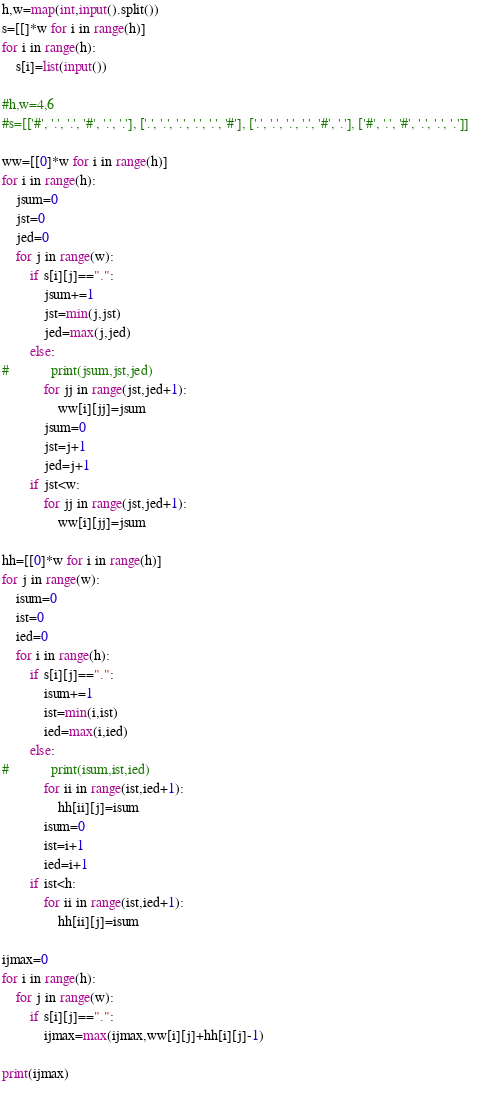<code> <loc_0><loc_0><loc_500><loc_500><_Python_>h,w=map(int,input().split())
s=[[]*w for i in range(h)]
for i in range(h):
    s[i]=list(input())

#h,w=4,6
#s=[['#', '.', '.', '#', '.', '.'], ['.', '.', '.', '.', '.', '#'], ['.', '.', '.', '.', '#', '.'], ['#', '.', '#', '.', '.', '.']]    

ww=[[0]*w for i in range(h)]
for i in range(h):
    jsum=0
    jst=0
    jed=0
    for j in range(w):
        if s[i][j]==".":
            jsum+=1
            jst=min(j,jst)
            jed=max(j,jed)
        else:
#            print(jsum,jst,jed)
            for jj in range(jst,jed+1):
                ww[i][jj]=jsum
            jsum=0
            jst=j+1
            jed=j+1
        if jst<w:
            for jj in range(jst,jed+1):
                ww[i][jj]=jsum
                
hh=[[0]*w for i in range(h)]
for j in range(w):
    isum=0
    ist=0
    ied=0
    for i in range(h):
        if s[i][j]==".":
            isum+=1
            ist=min(i,ist)
            ied=max(i,ied)
        else:
#            print(isum,ist,ied)
            for ii in range(ist,ied+1):
                hh[ii][j]=isum
            isum=0
            ist=i+1
            ied=i+1
        if ist<h:
            for ii in range(ist,ied+1):
                hh[ii][j]=isum
            
ijmax=0
for i in range(h):
    for j in range(w):
        if s[i][j]==".":
            ijmax=max(ijmax,ww[i][j]+hh[i][j]-1)

print(ijmax)
                
</code> 